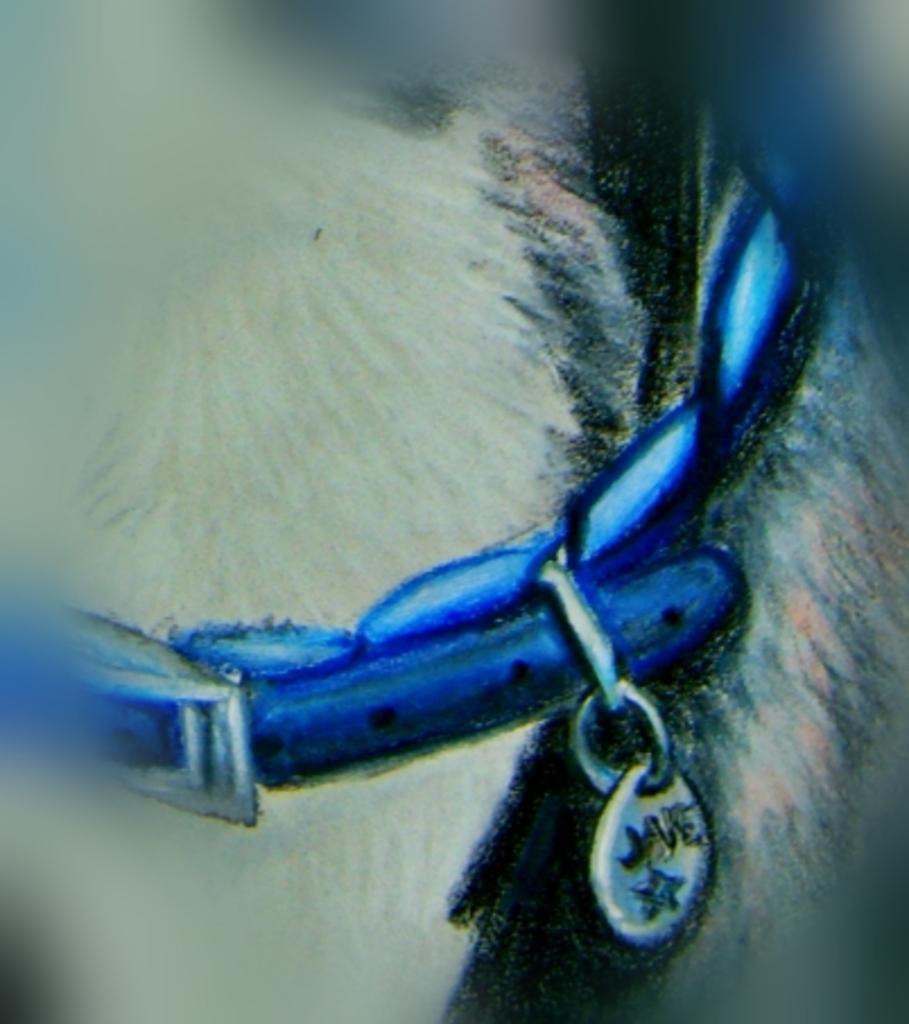How would you summarize this image in a sentence or two? In this image we can see the picture of a belt to an animal. 